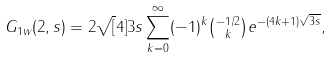Convert formula to latex. <formula><loc_0><loc_0><loc_500><loc_500>G _ { 1 w } ( 2 , s ) = 2 \sqrt { [ } 4 ] { 3 s } \sum _ { k = 0 } ^ { \infty } ( - 1 ) ^ { k } \tbinom { - 1 / 2 } { k } e ^ { - ( 4 k + 1 ) \sqrt { 3 s } } ,</formula> 